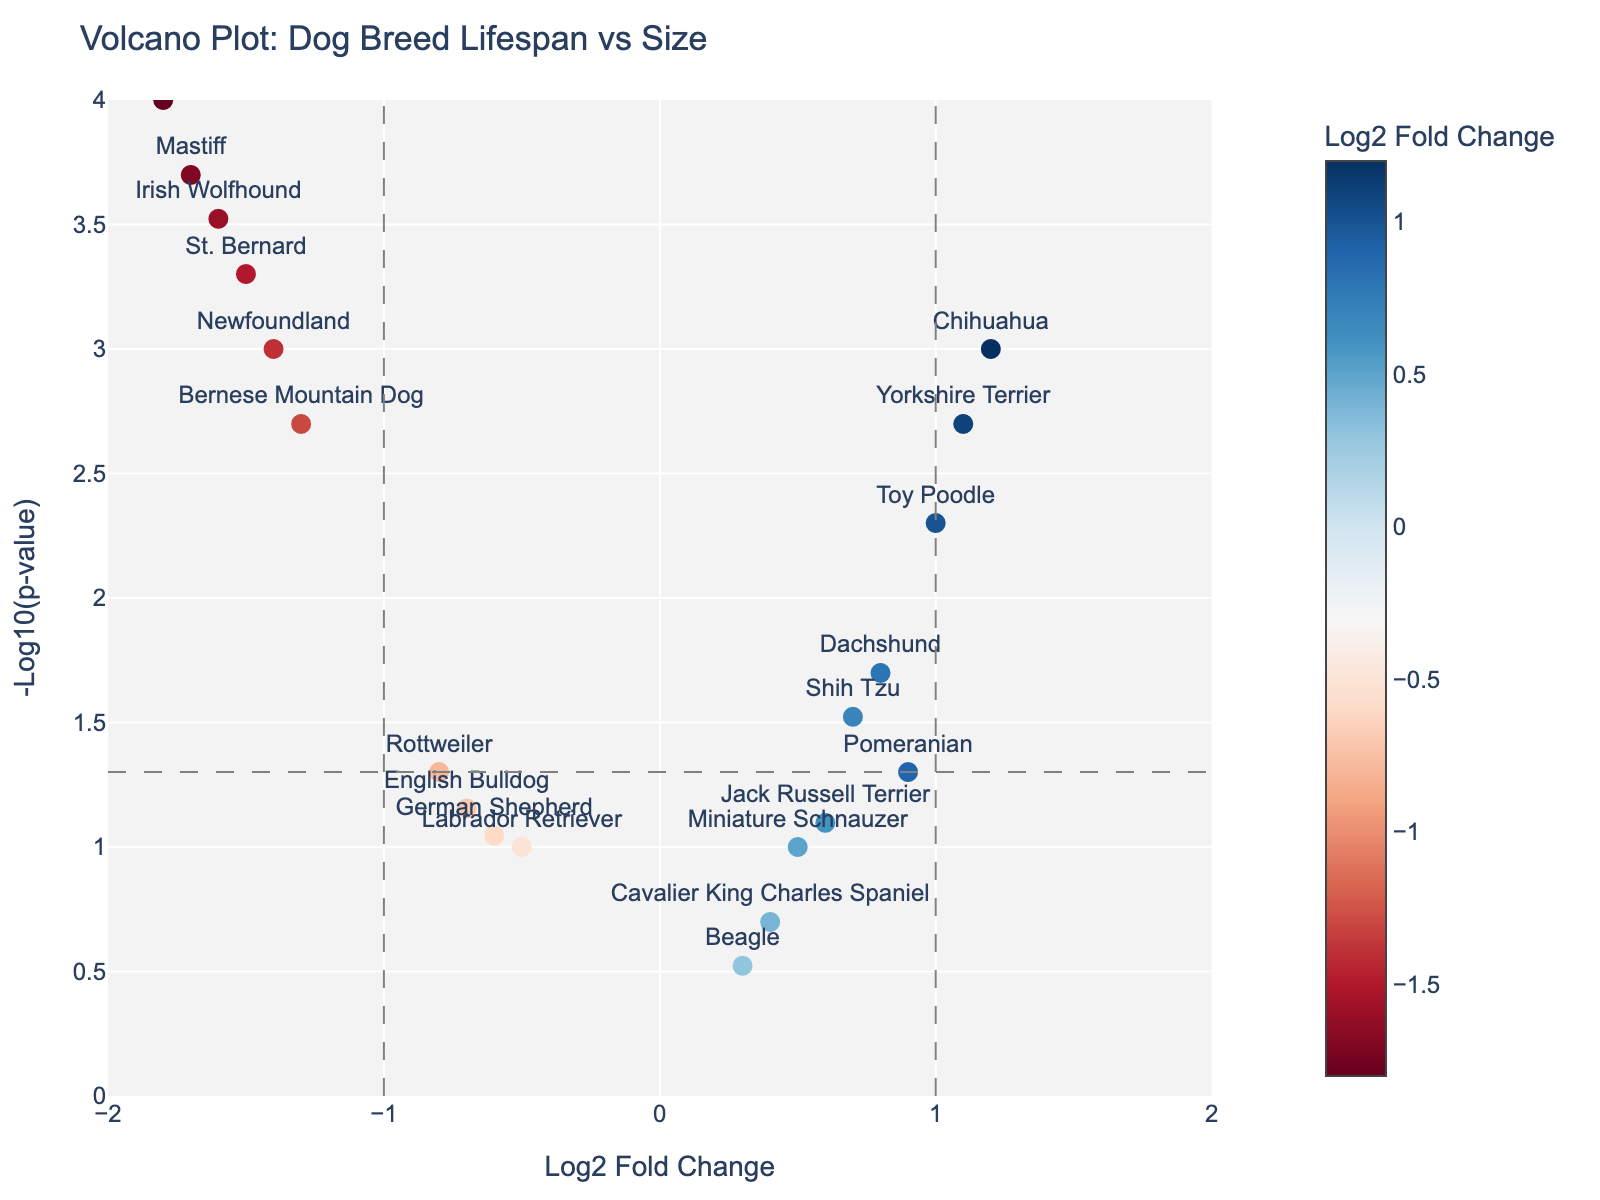How many dog breeds are included in the volcano plot? Count the number of unique data points (breeds) in the figure.
Answer: 20 Which breed has the highest -log10(p-value) and what is its corresponding log2 fold change? Find the breed with the highest y-value (-log10(p-value)), and read its corresponding x-value (log2 fold change). The highest -log10(p-value) is for Great Dane, which has a log2 fold change of -1.8.
Answer: Great Dane, -1.8 Which breeds have a log2 fold change greater than 1? Identify the breeds on the right side of the vertical line x=1. They are Chihuahua, Yorkshire Terrier, and Toy Poodle.
Answer: Chihuahua, Yorkshire Terrier, Toy Poodle Are there more breeds with negative or positive log2 fold change? Count the number of breeds with log2 fold changes greater than 0 (positive) and less than 0 (negative). There are more breeds with negative log2 fold changes.
Answer: Negative Which breed has the most statistically significant p-value and what is its value? The most statistically significant p-value corresponds to the highest -log10(p-value). The breed is Great Dane with a p-value of 0.0001.
Answer: Great Dane, 0.0001 Among the large breeds (log2 fold change < -1), which breed has the least statistically significant p-value? Look for breeds with log2 fold change < -1 and find the one with the lowest -log10(p-value), which is Bernese Mountain Dog (0.002 p-value).
Answer: Bernese Mountain Dog How many breeds have a statistically significant p-value (p < 0.05)? Count the number of data points above the horizontal line that represents p = 0.05 (-log10(p-value) ≈ 1.3). There are 10 such breeds.
Answer: 10 Which breed has a log2 fold change closest to zero but is still negative? Identify the breed closest to the line x=0 but on the negative side. It is Labrador Retriever with a log2 fold change of -0.5.
Answer: Labrador Retriever Which small breed (log2 fold change > 0) has the highest p-value? Among the breeds with log2 fold changes greater than 0, find the one with the lowest -log10(p-value), which is Pomeranian.
Answer: Pomeranian How many breeds have log2 fold changes between -1 and 1 inclusive? Count the number of data points between the vertical lines x=-1 and x=1 (inclusive). There are 8 breeds in this range.
Answer: 8 